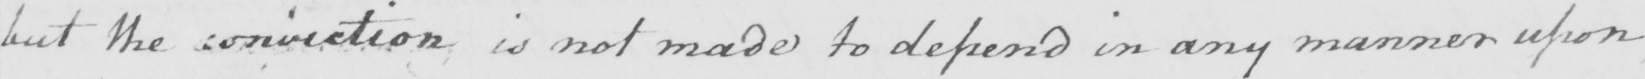Can you tell me what this handwritten text says? but the conviction is not made to depend in any manner upon 